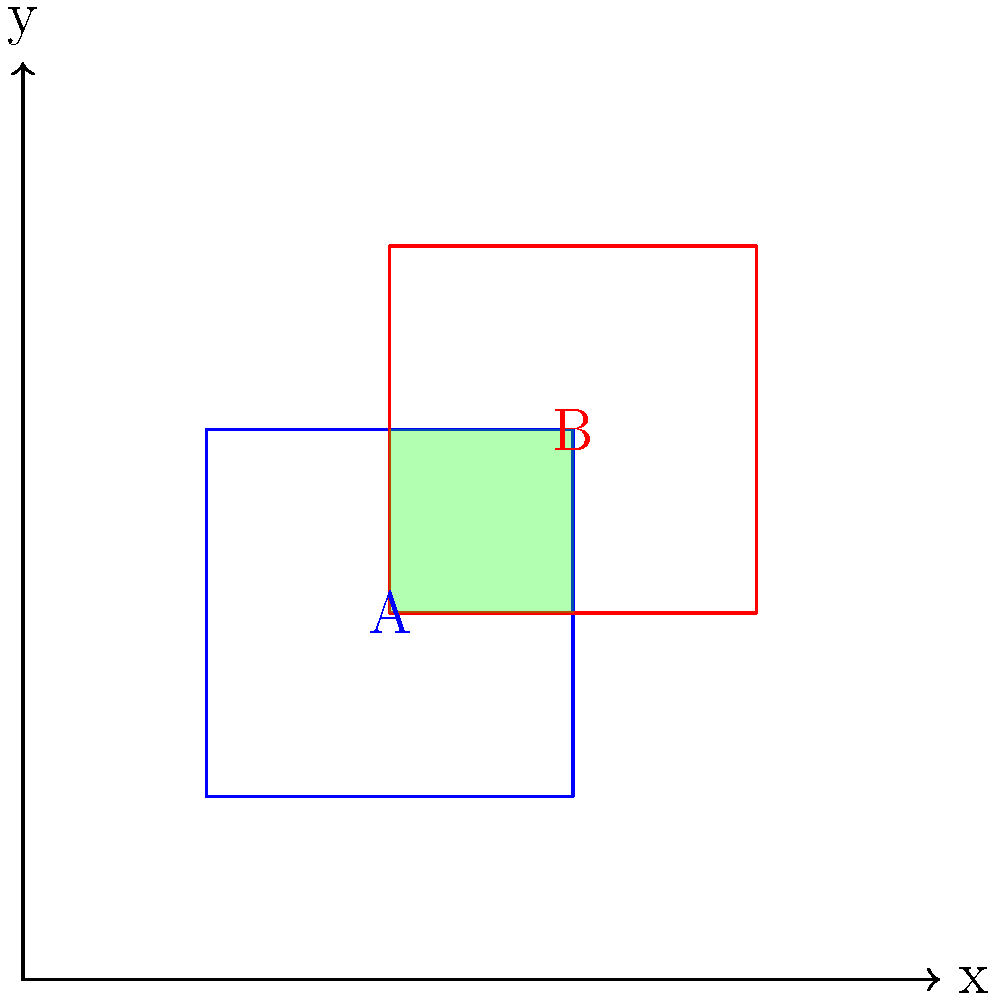Two property deeds overlap on a coordinate grid as shown above. Property A is represented by the blue square, and Property B by the red square. The overlapping area is highlighted in green. If the grid represents 1 acre per unit square, what is the area of the disputed (overlapping) region in acres, and what percentage does this represent of the smaller property's total area? To solve this problem, let's follow these steps:

1. Calculate the area of the overlapping region:
   - The overlapping region is a square with sides of length 2 units.
   - Area of overlap = $2 \times 2 = 4$ square units
   - Since each unit square represents 1 acre, the overlapping area is 4 acres.

2. Calculate the total area of each property:
   - Property A: $4 \times 4 = 16$ square units = 16 acres
   - Property B: $4 \times 4 = 16$ square units = 16 acres

3. Determine which property is smaller:
   - Both properties have the same area, so we can use either for our percentage calculation.

4. Calculate the percentage of the overlapping area relative to the total area of one property:
   - Percentage = (Area of overlap / Total area of property) $\times 100\%$
   - Percentage = $(4 / 16) \times 100\% = 0.25 \times 100\% = 25\%$

Therefore, the overlapping (disputed) area is 4 acres, which represents 25% of either property's total area.
Answer: 4 acres; 25% 